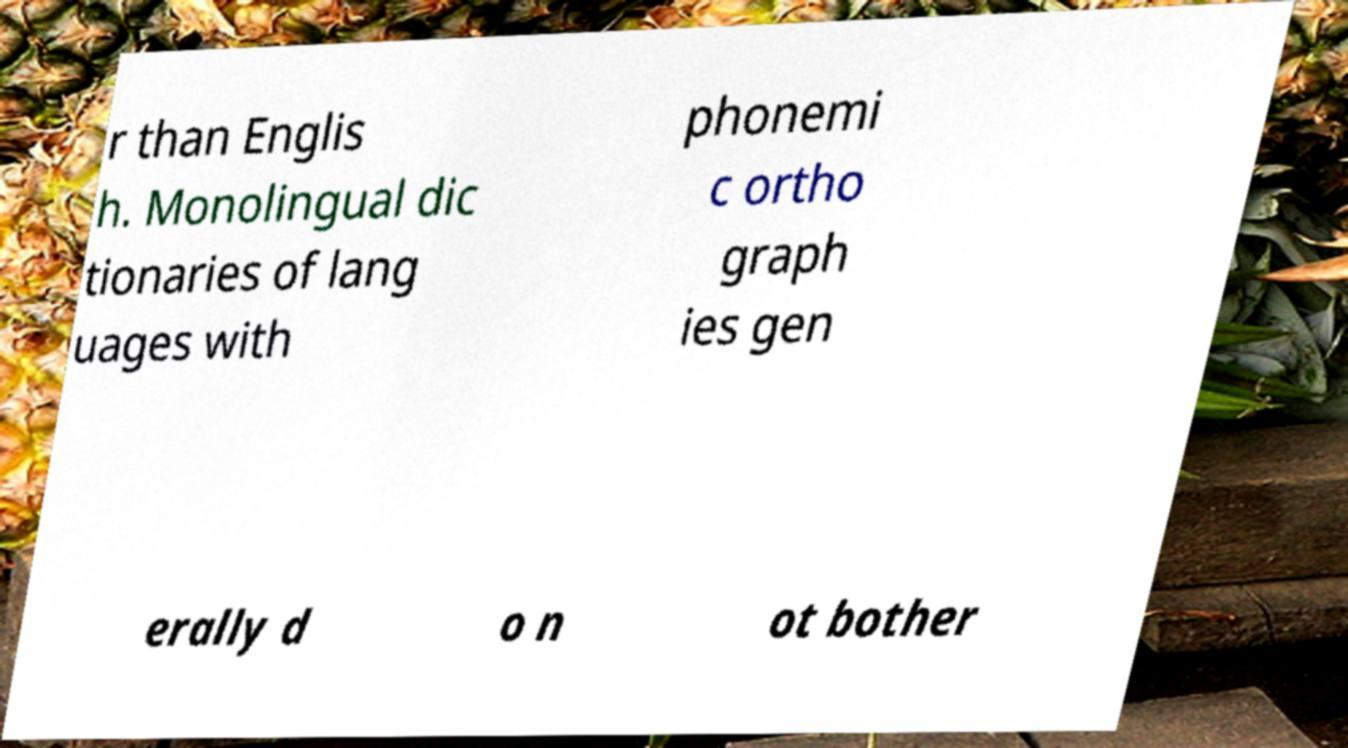I need the written content from this picture converted into text. Can you do that? r than Englis h. Monolingual dic tionaries of lang uages with phonemi c ortho graph ies gen erally d o n ot bother 